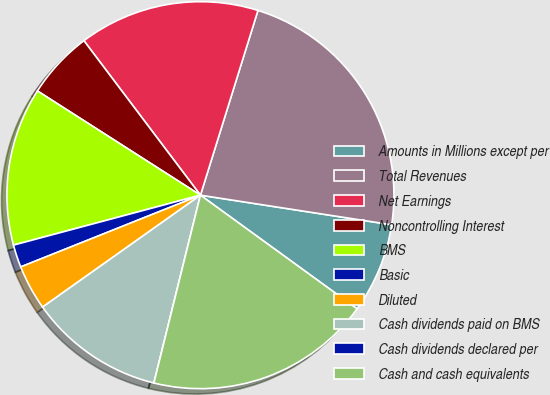<chart> <loc_0><loc_0><loc_500><loc_500><pie_chart><fcel>Amounts in Millions except per<fcel>Total Revenues<fcel>Net Earnings<fcel>Noncontrolling Interest<fcel>BMS<fcel>Basic<fcel>Diluted<fcel>Cash dividends paid on BMS<fcel>Cash dividends declared per<fcel>Cash and cash equivalents<nl><fcel>7.55%<fcel>22.64%<fcel>15.09%<fcel>5.66%<fcel>13.21%<fcel>1.89%<fcel>3.77%<fcel>11.32%<fcel>0.0%<fcel>18.87%<nl></chart> 